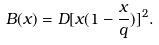<formula> <loc_0><loc_0><loc_500><loc_500>B ( x ) = D [ x ( 1 - \frac { x } { q } ) ] ^ { 2 } .</formula> 